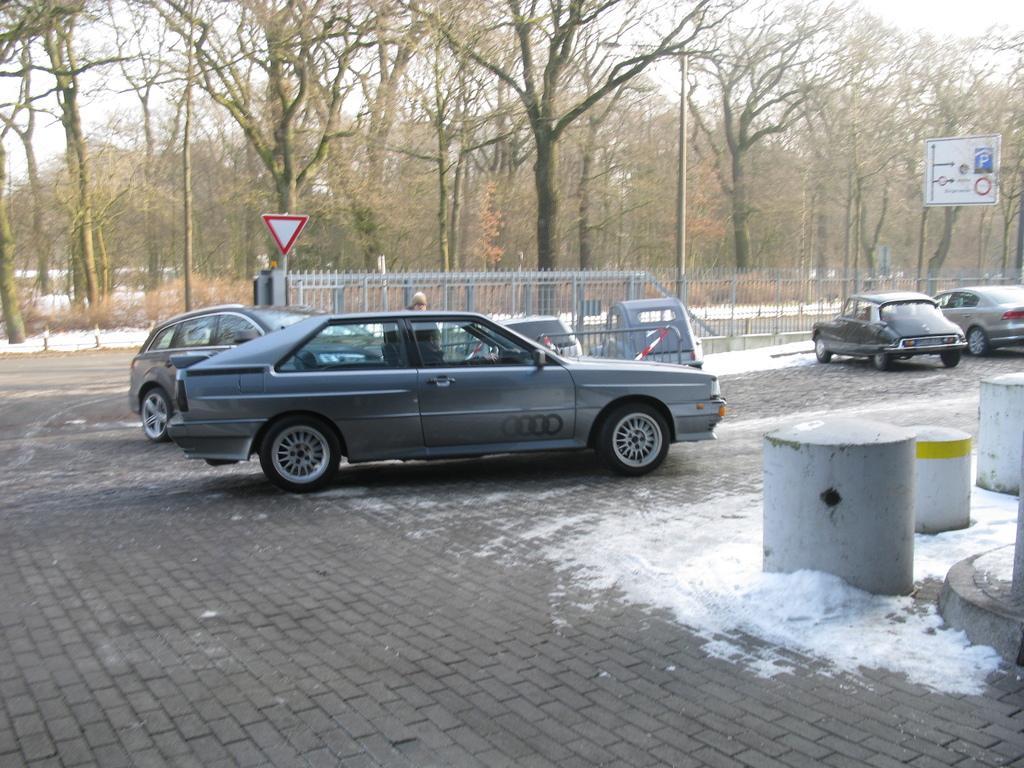In one or two sentences, can you explain what this image depicts? In this image I can see few vehicles and I can also see the person. In the background I can see the railing, board and the pole and I can also see few trees and the sky is in white color. 